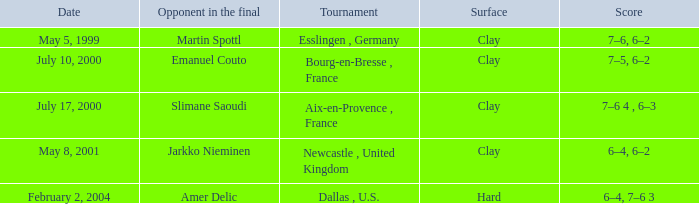What is the Date of the game with a Score of 6–4, 6–2? May 8, 2001. 